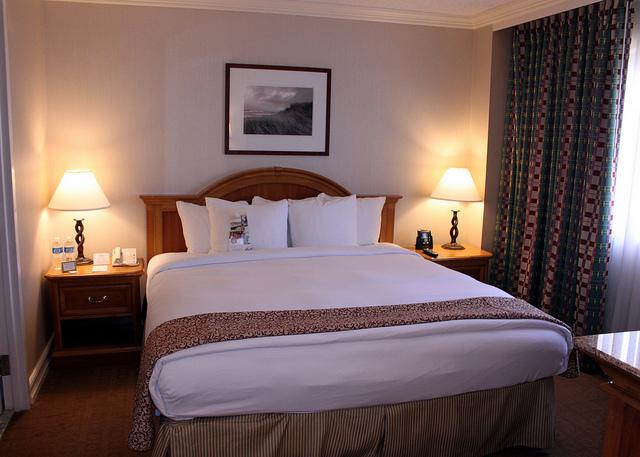What color is the wall?
Give a very brief answer. White. What size bed is this?
Concise answer only. King. What color is the comforter?
Short answer required. White. 